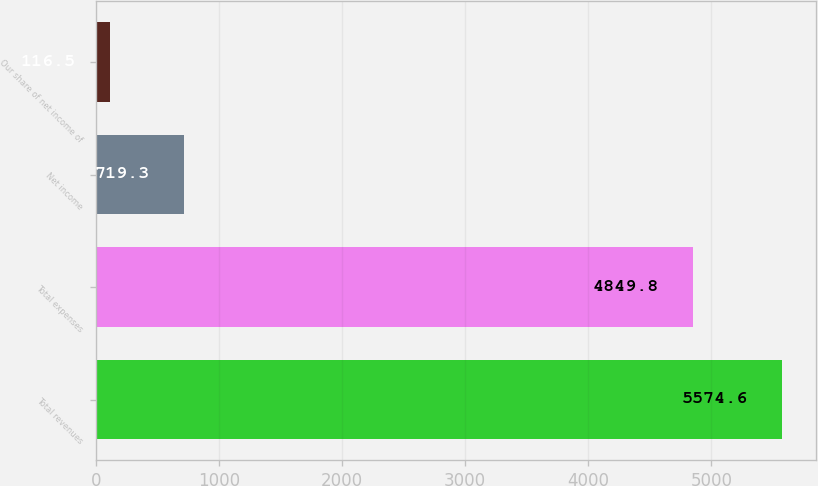<chart> <loc_0><loc_0><loc_500><loc_500><bar_chart><fcel>Total revenues<fcel>Total expenses<fcel>Net income<fcel>Our share of net income of<nl><fcel>5574.6<fcel>4849.8<fcel>719.3<fcel>116.5<nl></chart> 